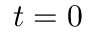<formula> <loc_0><loc_0><loc_500><loc_500>t = 0</formula> 